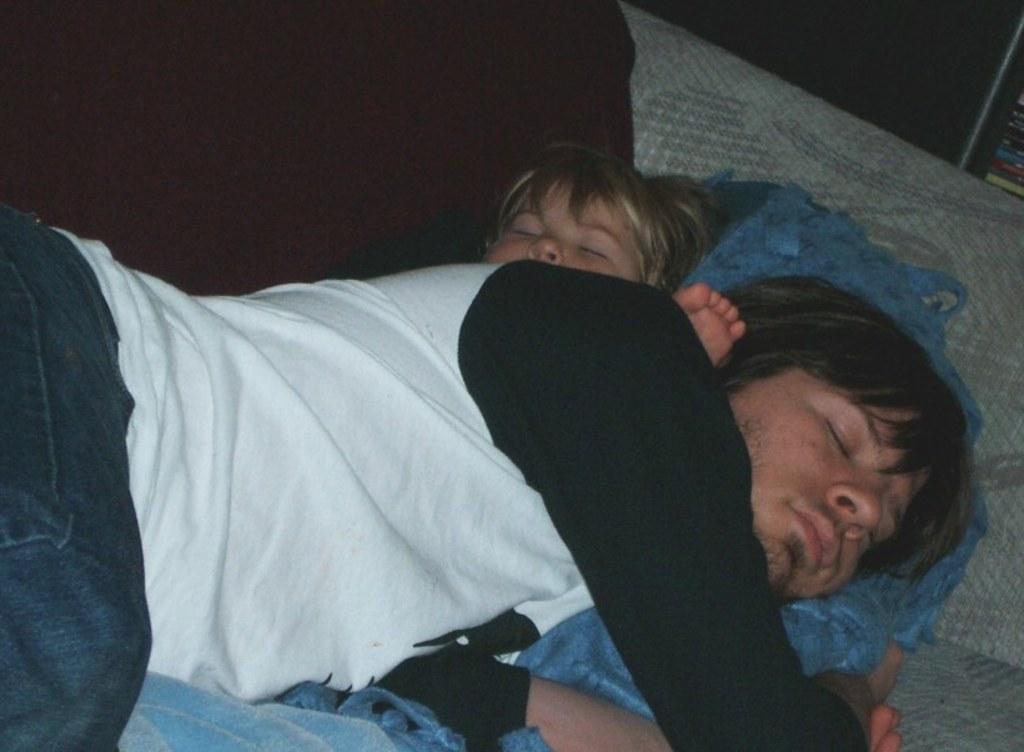Describe this image in one or two sentences. In this image we can see two persons sleeping on the bed and there are blankets on the bed. 